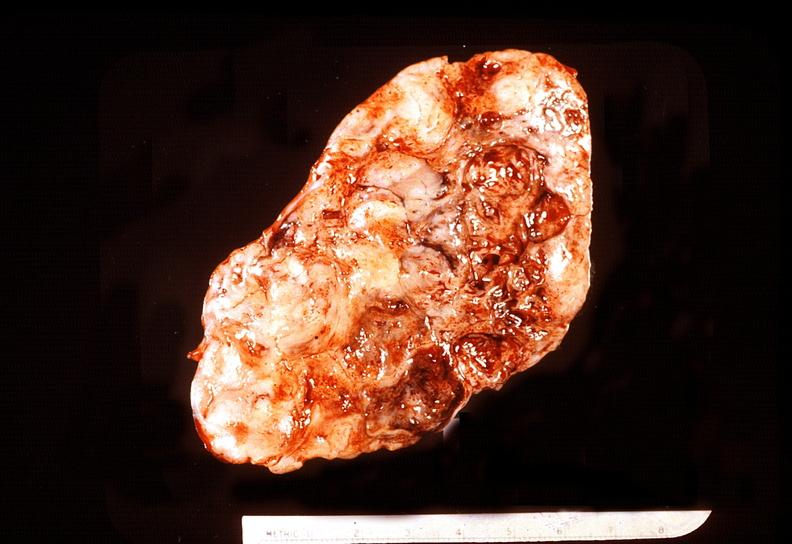does this image show adrenal phaeochromocytoma?
Answer the question using a single word or phrase. Yes 